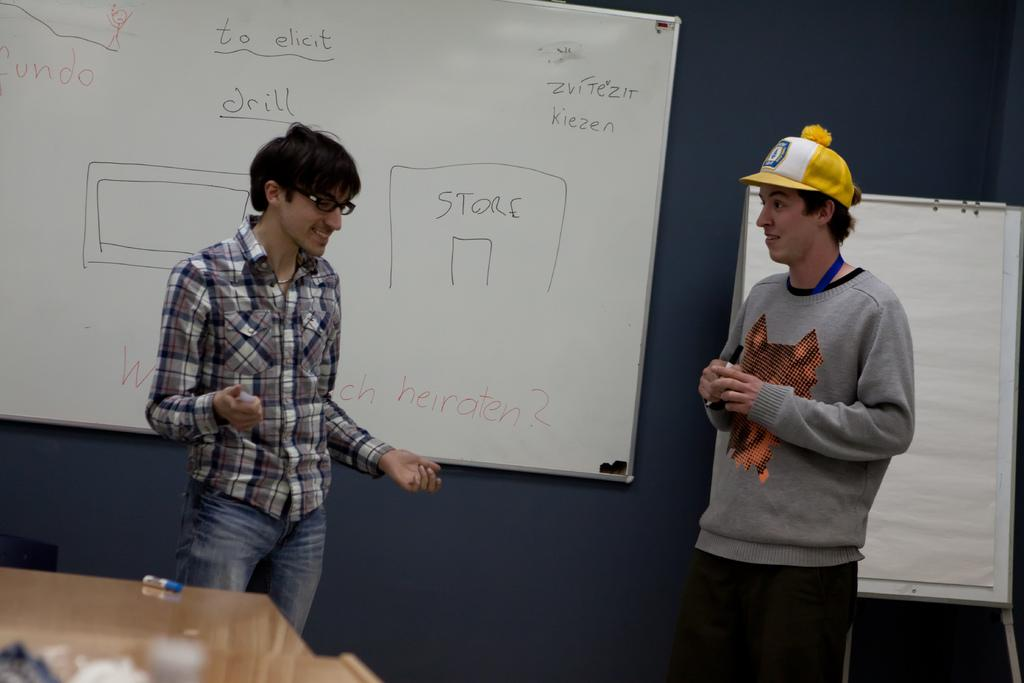<image>
Share a concise interpretation of the image provided. A man in a yellow hat stands near a whiteboard that says "Store" 